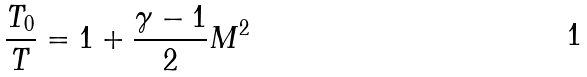<formula> <loc_0><loc_0><loc_500><loc_500>\frac { T _ { 0 } } { T } = 1 + \frac { \gamma - 1 } { 2 } M ^ { 2 }</formula> 